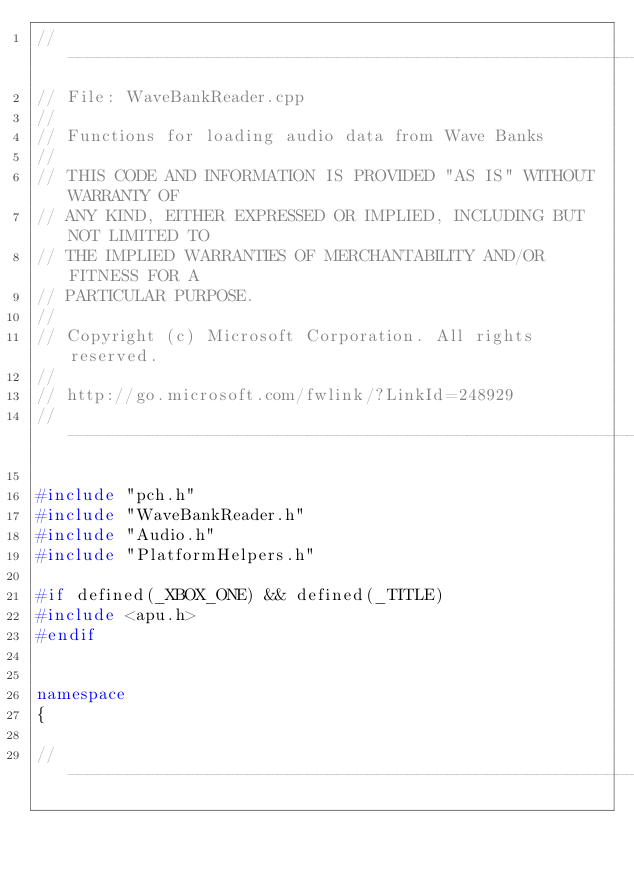<code> <loc_0><loc_0><loc_500><loc_500><_C++_>//--------------------------------------------------------------------------------------
// File: WaveBankReader.cpp
//
// Functions for loading audio data from Wave Banks
//
// THIS CODE AND INFORMATION IS PROVIDED "AS IS" WITHOUT WARRANTY OF
// ANY KIND, EITHER EXPRESSED OR IMPLIED, INCLUDING BUT NOT LIMITED TO
// THE IMPLIED WARRANTIES OF MERCHANTABILITY AND/OR FITNESS FOR A
// PARTICULAR PURPOSE.
//
// Copyright (c) Microsoft Corporation. All rights reserved.
//
// http://go.microsoft.com/fwlink/?LinkId=248929
//-------------------------------------------------------------------------------------

#include "pch.h"
#include "WaveBankReader.h"
#include "Audio.h"
#include "PlatformHelpers.h"

#if defined(_XBOX_ONE) && defined(_TITLE)
#include <apu.h>
#endif


namespace
{
    
//--------------------------------------------------------------------------------------</code> 